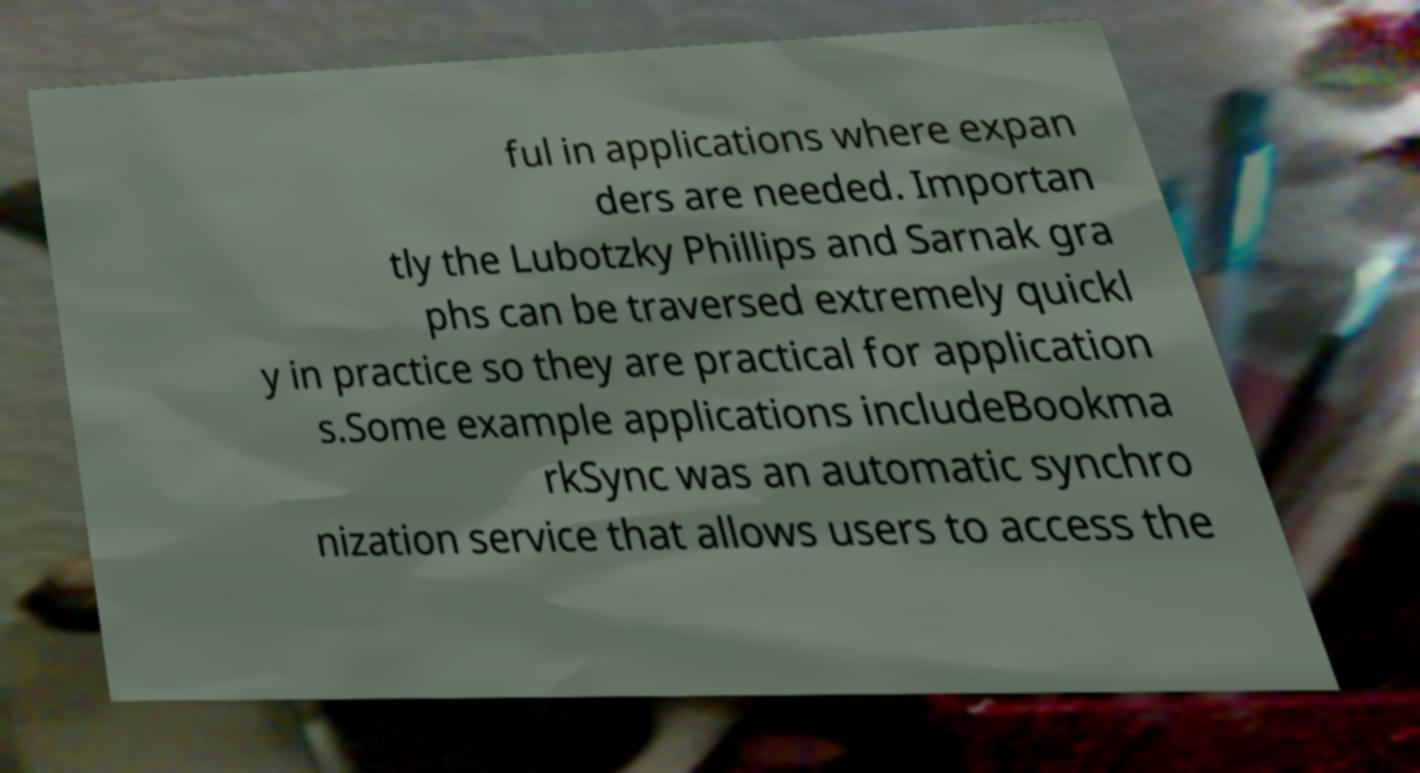What messages or text are displayed in this image? I need them in a readable, typed format. ful in applications where expan ders are needed. Importan tly the Lubotzky Phillips and Sarnak gra phs can be traversed extremely quickl y in practice so they are practical for application s.Some example applications includeBookma rkSync was an automatic synchro nization service that allows users to access the 